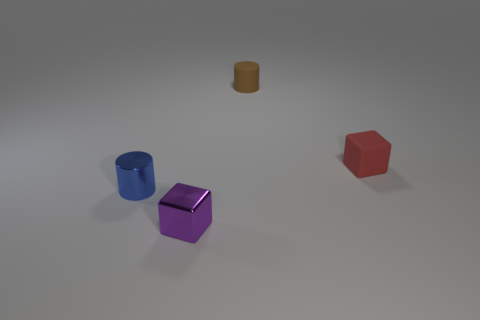There is a blue metal thing that is the same size as the brown thing; what shape is it?
Provide a succinct answer. Cylinder. What number of things are either large blue matte cylinders or small objects?
Offer a very short reply. 4. There is a object on the left side of the small purple thing; does it have the same shape as the rubber thing that is to the left of the red thing?
Provide a short and direct response. Yes. There is a tiny object that is in front of the small blue object; what shape is it?
Offer a terse response. Cube. Are there an equal number of purple metal blocks on the right side of the red matte cube and small rubber objects in front of the brown cylinder?
Offer a terse response. No. What number of things are tiny red cylinders or things behind the red object?
Offer a terse response. 1. What shape is the thing that is on the right side of the small purple cube and left of the red object?
Offer a terse response. Cylinder. What is the material of the thing on the left side of the purple block that is right of the small blue metal cylinder?
Keep it short and to the point. Metal. Are the cylinder that is to the right of the blue metallic object and the tiny red thing made of the same material?
Make the answer very short. Yes. What size is the cube that is in front of the tiny blue shiny cylinder?
Make the answer very short. Small. 